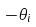<formula> <loc_0><loc_0><loc_500><loc_500>- \theta _ { i }</formula> 